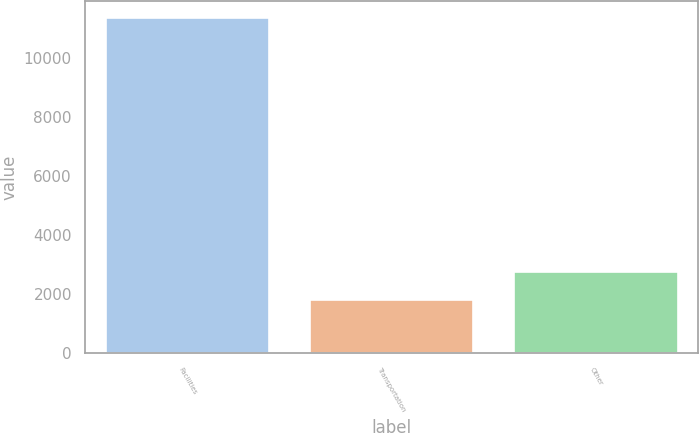Convert chart to OTSL. <chart><loc_0><loc_0><loc_500><loc_500><bar_chart><fcel>Facilities<fcel>Transportation<fcel>Other<nl><fcel>11378<fcel>1805<fcel>2762.3<nl></chart> 